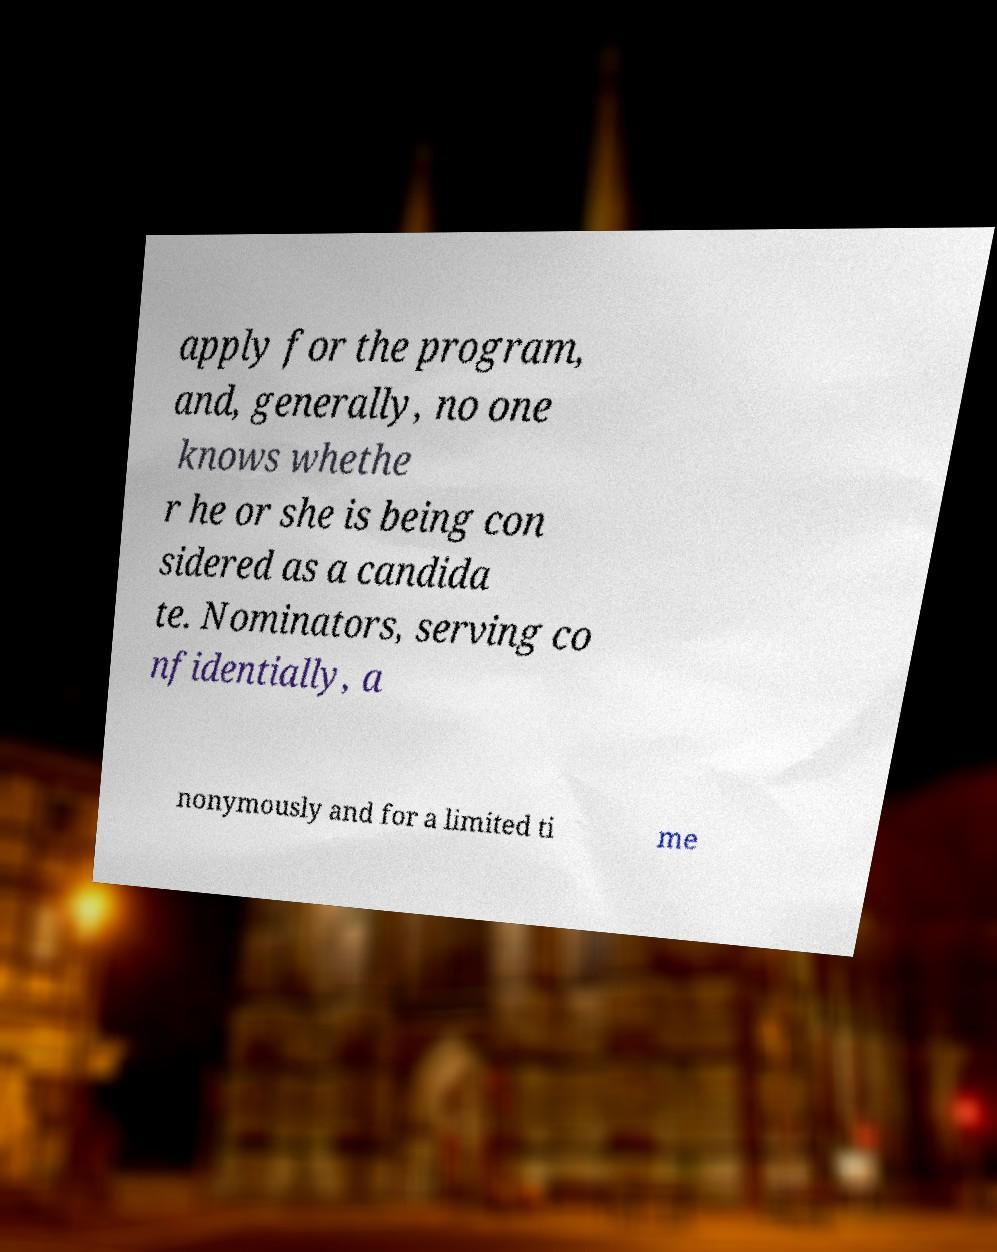Could you assist in decoding the text presented in this image and type it out clearly? apply for the program, and, generally, no one knows whethe r he or she is being con sidered as a candida te. Nominators, serving co nfidentially, a nonymously and for a limited ti me 